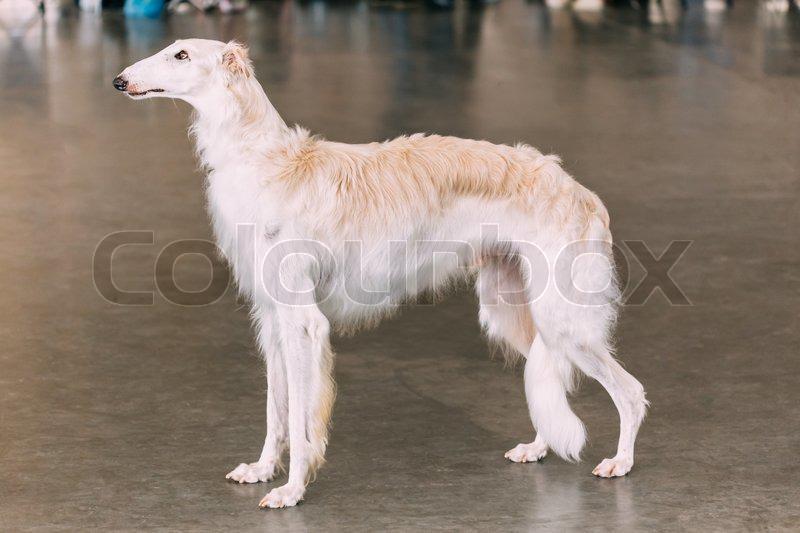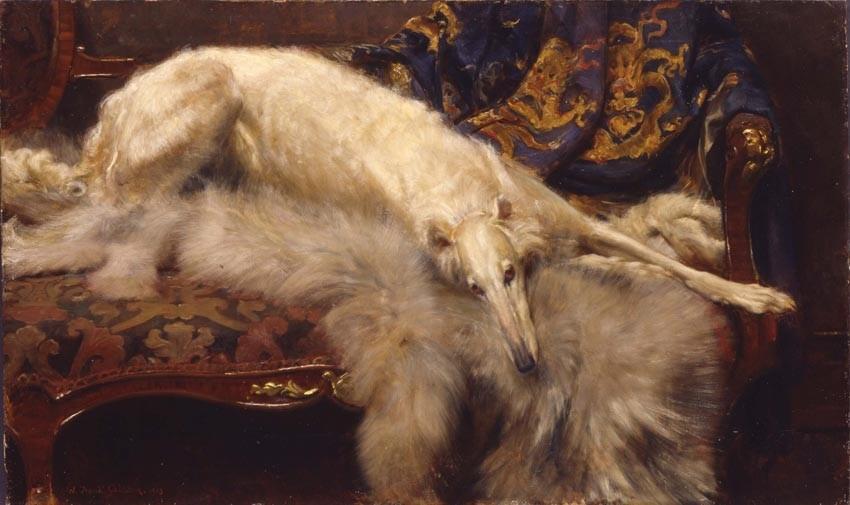The first image is the image on the left, the second image is the image on the right. Evaluate the accuracy of this statement regarding the images: "In one image there is a lone Russian Wolfhound standing with its nose pointing to the left of the image.". Is it true? Answer yes or no. Yes. 